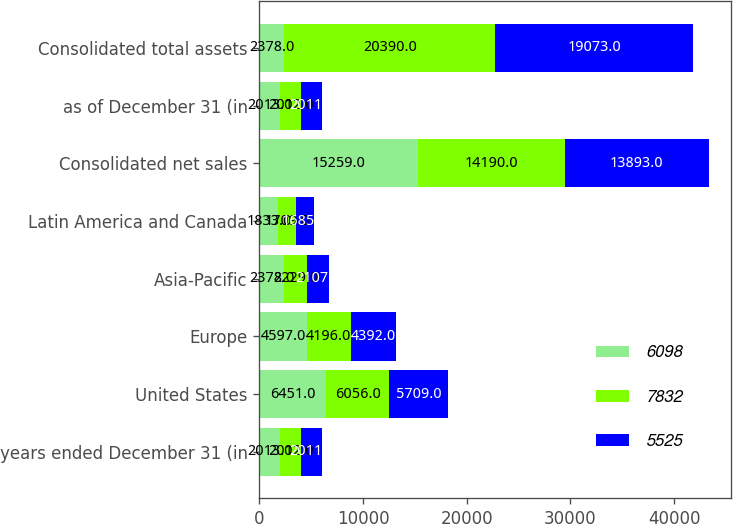<chart> <loc_0><loc_0><loc_500><loc_500><stacked_bar_chart><ecel><fcel>years ended December 31 (in<fcel>United States<fcel>Europe<fcel>Asia-Pacific<fcel>Latin America and Canada<fcel>Consolidated net sales<fcel>as of December 31 (in<fcel>Consolidated total assets<nl><fcel>6098<fcel>2013<fcel>6451<fcel>4597<fcel>2378<fcel>1833<fcel>15259<fcel>2013<fcel>2378<nl><fcel>7832<fcel>2012<fcel>6056<fcel>4196<fcel>2229<fcel>1709<fcel>14190<fcel>2012<fcel>20390<nl><fcel>5525<fcel>2011<fcel>5709<fcel>4392<fcel>2107<fcel>1685<fcel>13893<fcel>2011<fcel>19073<nl></chart> 